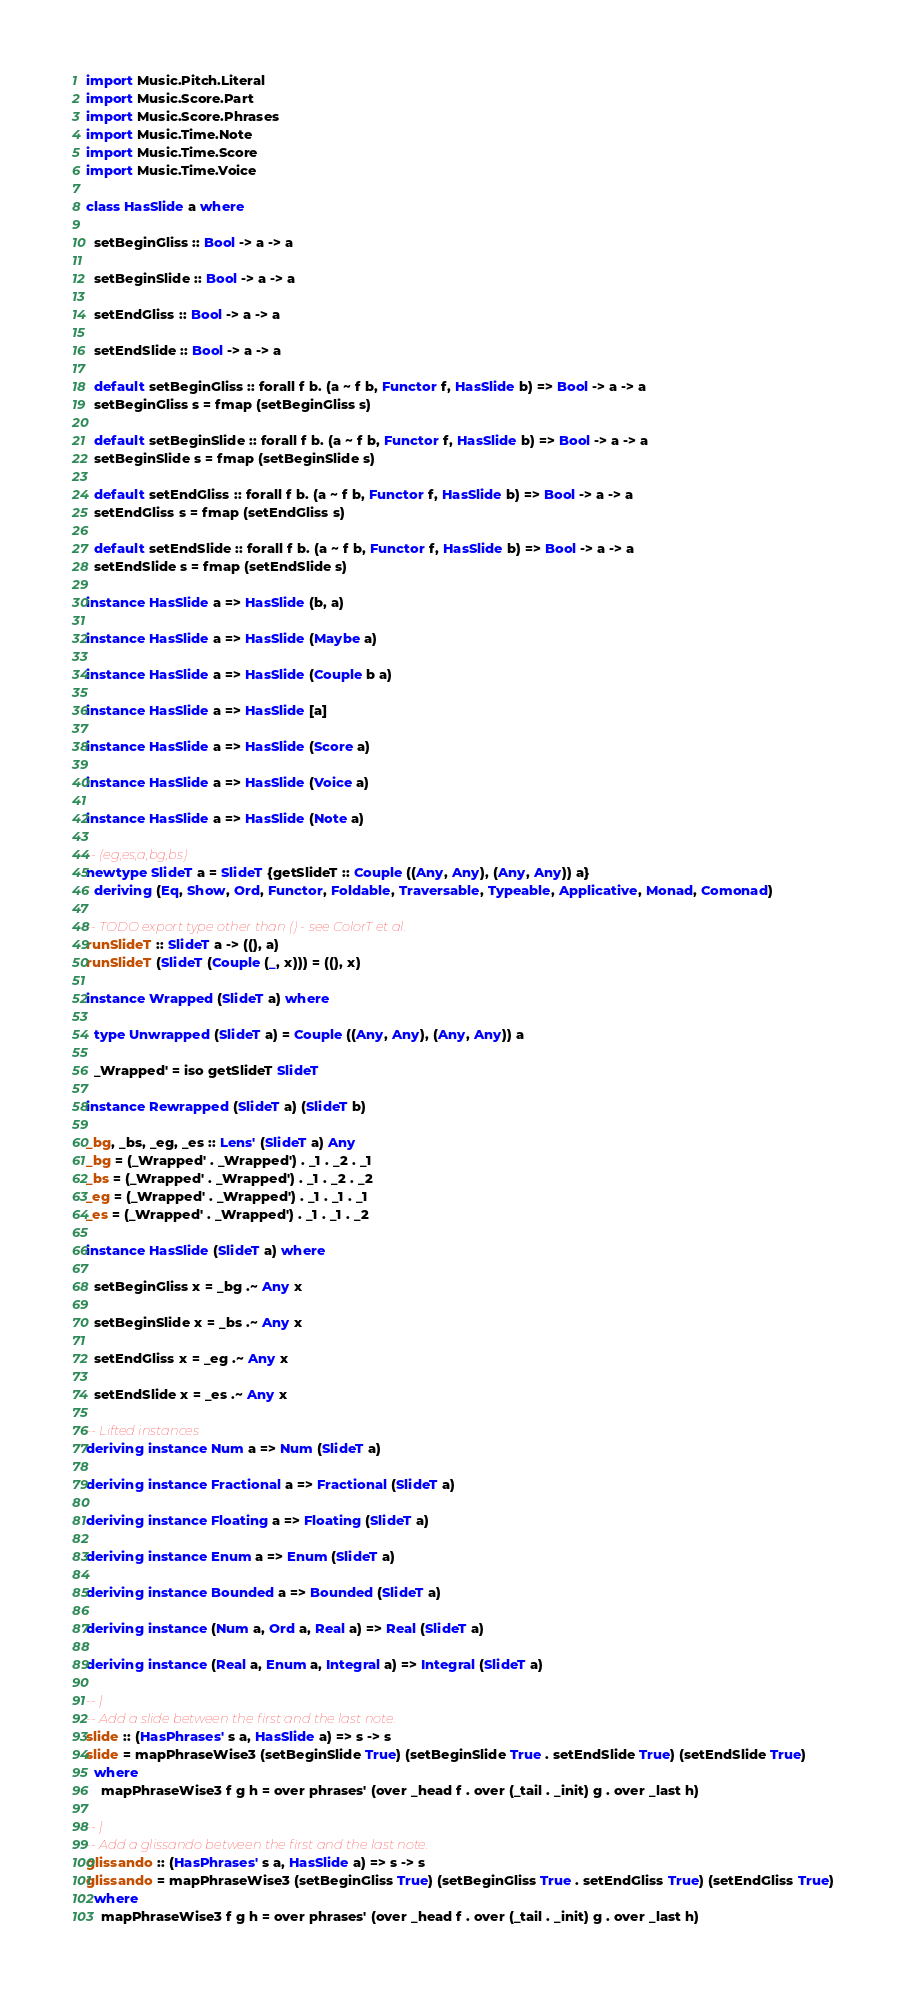<code> <loc_0><loc_0><loc_500><loc_500><_Haskell_>import Music.Pitch.Literal
import Music.Score.Part
import Music.Score.Phrases
import Music.Time.Note
import Music.Time.Score
import Music.Time.Voice

class HasSlide a where

  setBeginGliss :: Bool -> a -> a

  setBeginSlide :: Bool -> a -> a

  setEndGliss :: Bool -> a -> a

  setEndSlide :: Bool -> a -> a

  default setBeginGliss :: forall f b. (a ~ f b, Functor f, HasSlide b) => Bool -> a -> a
  setBeginGliss s = fmap (setBeginGliss s)

  default setBeginSlide :: forall f b. (a ~ f b, Functor f, HasSlide b) => Bool -> a -> a
  setBeginSlide s = fmap (setBeginSlide s)

  default setEndGliss :: forall f b. (a ~ f b, Functor f, HasSlide b) => Bool -> a -> a
  setEndGliss s = fmap (setEndGliss s)

  default setEndSlide :: forall f b. (a ~ f b, Functor f, HasSlide b) => Bool -> a -> a
  setEndSlide s = fmap (setEndSlide s)

instance HasSlide a => HasSlide (b, a)

instance HasSlide a => HasSlide (Maybe a)

instance HasSlide a => HasSlide (Couple b a)

instance HasSlide a => HasSlide [a]

instance HasSlide a => HasSlide (Score a)

instance HasSlide a => HasSlide (Voice a)

instance HasSlide a => HasSlide (Note a)

-- (eg,es,a,bg,bs)
newtype SlideT a = SlideT {getSlideT :: Couple ((Any, Any), (Any, Any)) a}
  deriving (Eq, Show, Ord, Functor, Foldable, Traversable, Typeable, Applicative, Monad, Comonad)

-- TODO export type other than () - see ColorT et al.
runSlideT :: SlideT a -> ((), a)
runSlideT (SlideT (Couple (_, x))) = ((), x)

instance Wrapped (SlideT a) where

  type Unwrapped (SlideT a) = Couple ((Any, Any), (Any, Any)) a

  _Wrapped' = iso getSlideT SlideT

instance Rewrapped (SlideT a) (SlideT b)

_bg, _bs, _eg, _es :: Lens' (SlideT a) Any
_bg = (_Wrapped' . _Wrapped') . _1 . _2 . _1
_bs = (_Wrapped' . _Wrapped') . _1 . _2 . _2
_eg = (_Wrapped' . _Wrapped') . _1 . _1 . _1
_es = (_Wrapped' . _Wrapped') . _1 . _1 . _2

instance HasSlide (SlideT a) where

  setBeginGliss x = _bg .~ Any x

  setBeginSlide x = _bs .~ Any x

  setEndGliss x = _eg .~ Any x

  setEndSlide x = _es .~ Any x

-- Lifted instances
deriving instance Num a => Num (SlideT a)

deriving instance Fractional a => Fractional (SlideT a)

deriving instance Floating a => Floating (SlideT a)

deriving instance Enum a => Enum (SlideT a)

deriving instance Bounded a => Bounded (SlideT a)

deriving instance (Num a, Ord a, Real a) => Real (SlideT a)

deriving instance (Real a, Enum a, Integral a) => Integral (SlideT a)

-- |
-- Add a slide between the first and the last note.
slide :: (HasPhrases' s a, HasSlide a) => s -> s
slide = mapPhraseWise3 (setBeginSlide True) (setBeginSlide True . setEndSlide True) (setEndSlide True)
  where
    mapPhraseWise3 f g h = over phrases' (over _head f . over (_tail . _init) g . over _last h)

-- |
-- Add a glissando between the first and the last note.
glissando :: (HasPhrases' s a, HasSlide a) => s -> s
glissando = mapPhraseWise3 (setBeginGliss True) (setBeginGliss True . setEndGliss True) (setEndGliss True)
  where
    mapPhraseWise3 f g h = over phrases' (over _head f . over (_tail . _init) g . over _last h)
</code> 